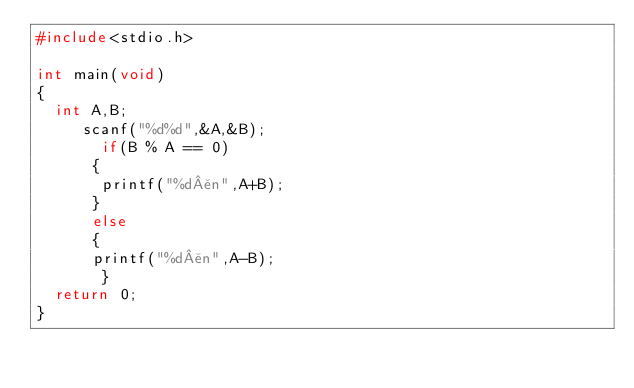<code> <loc_0><loc_0><loc_500><loc_500><_C_>#include<stdio.h>

int main(void)
{
  int A,B;
     scanf("%d%d",&A,&B);
       if(B % A == 0)
      {
       printf("%d¥n",A+B);
      }
      else
      {
      printf("%d¥n",A-B);
       }
  return 0;
}
</code> 